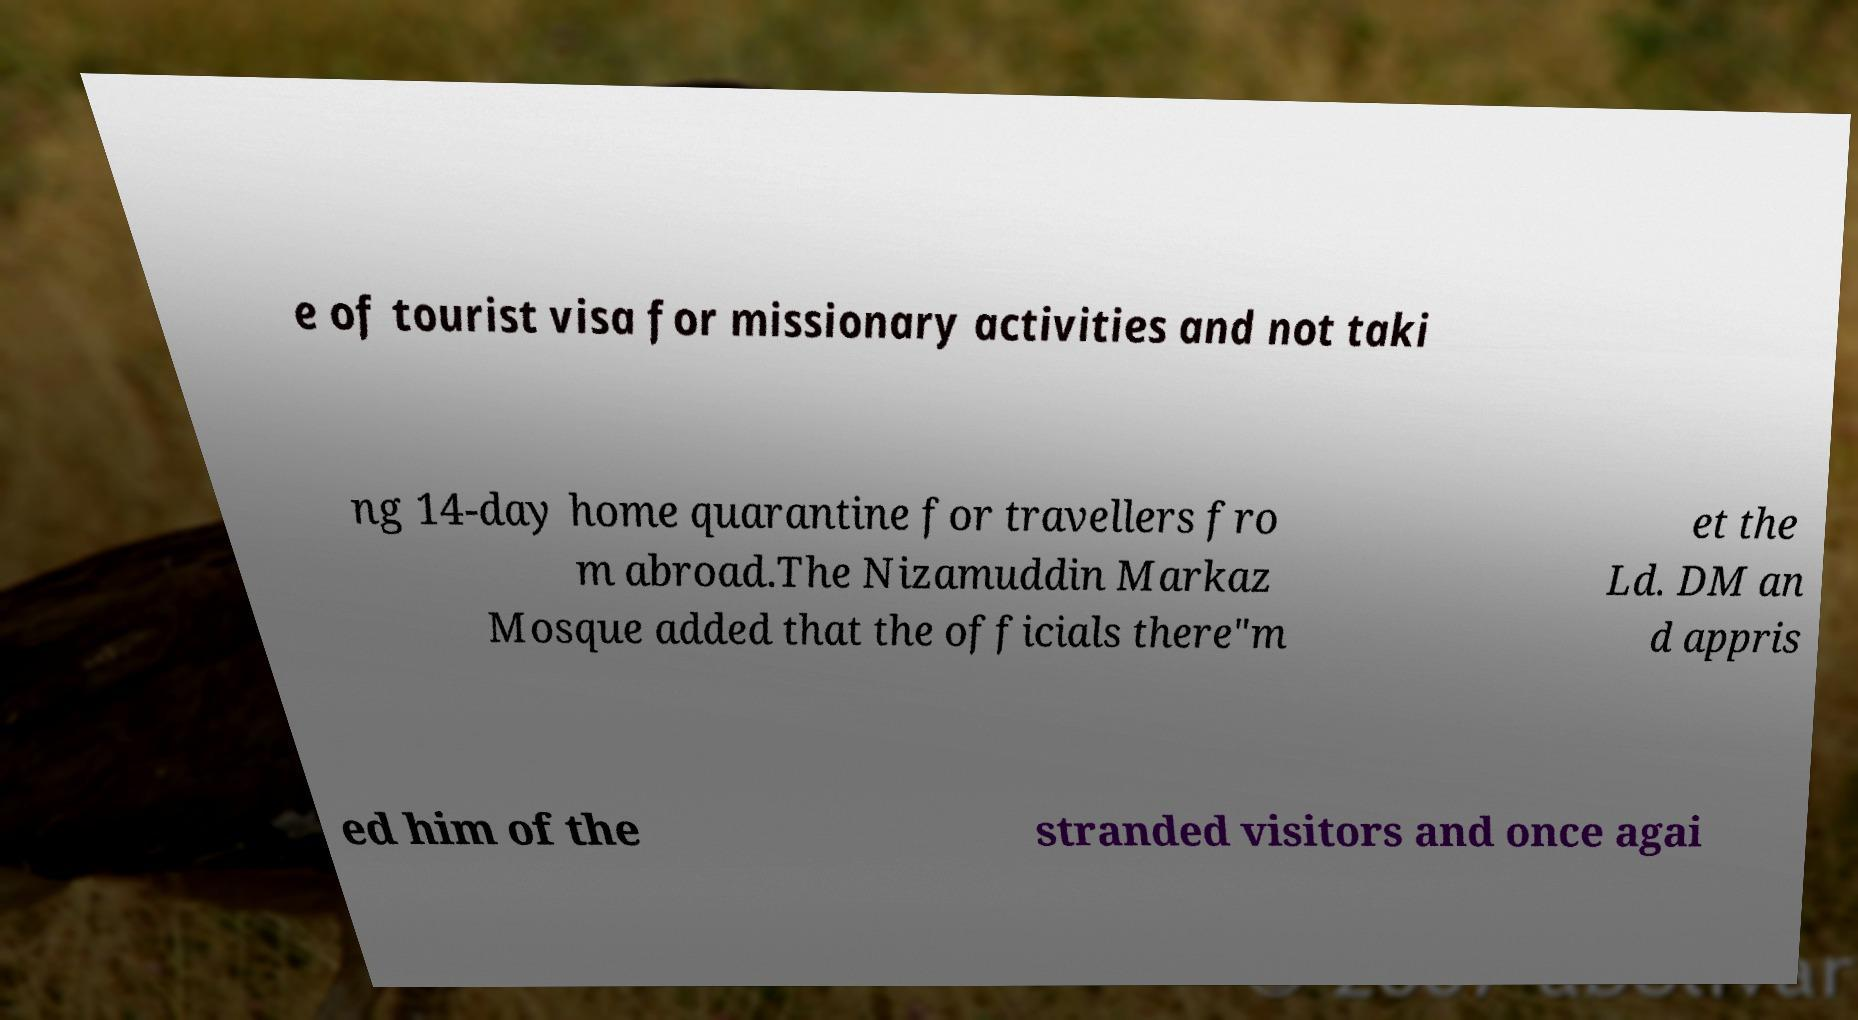What messages or text are displayed in this image? I need them in a readable, typed format. e of tourist visa for missionary activities and not taki ng 14-day home quarantine for travellers fro m abroad.The Nizamuddin Markaz Mosque added that the officials there"m et the Ld. DM an d appris ed him of the stranded visitors and once agai 